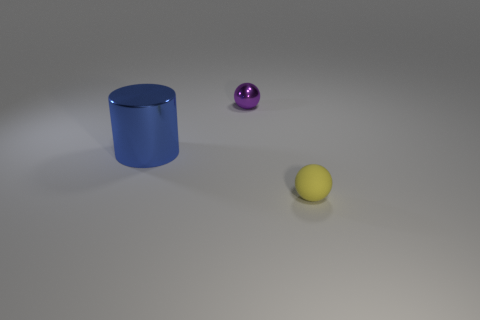There is a object that is in front of the small purple object and to the right of the large cylinder; what is its color?
Offer a terse response. Yellow. What number of other things are there of the same shape as the small yellow object?
Make the answer very short. 1. There is a thing that is left of the purple metal sphere; is it the same size as the sphere in front of the shiny ball?
Provide a short and direct response. No. Is there anything else that has the same material as the small yellow sphere?
Provide a short and direct response. No. What is the material of the small ball that is behind the small ball that is in front of the tiny ball that is to the left of the yellow matte sphere?
Offer a terse response. Metal. Is the shape of the purple object the same as the small yellow rubber object?
Your response must be concise. Yes. There is a small yellow thing that is the same shape as the purple thing; what material is it?
Offer a very short reply. Rubber. The blue cylinder that is made of the same material as the purple sphere is what size?
Your response must be concise. Large. What number of red objects are either metal objects or tiny shiny balls?
Ensure brevity in your answer.  0. How many objects are behind the small yellow ball on the right side of the cylinder?
Give a very brief answer. 2. 